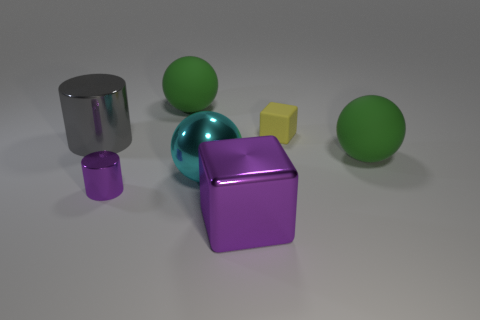Is there a big gray thing that has the same shape as the small purple shiny object?
Your answer should be compact. Yes. There is a large green ball on the right side of the big matte ball that is to the left of the purple object to the right of the tiny purple metal object; what is its material?
Ensure brevity in your answer.  Rubber. Are there any green things of the same size as the purple block?
Offer a very short reply. Yes. There is a rubber sphere that is behind the rubber ball that is in front of the yellow matte object; what is its color?
Your answer should be very brief. Green. What number of large purple blocks are there?
Give a very brief answer. 1. Do the small shiny thing and the large metallic block have the same color?
Ensure brevity in your answer.  Yes. Are there fewer big gray cylinders on the right side of the tiny purple cylinder than cubes that are behind the metallic ball?
Your answer should be compact. Yes. What is the color of the tiny shiny object?
Your answer should be very brief. Purple. How many tiny things are the same color as the large metallic cube?
Provide a short and direct response. 1. There is a cyan sphere; are there any big cyan metallic spheres in front of it?
Offer a very short reply. No. 